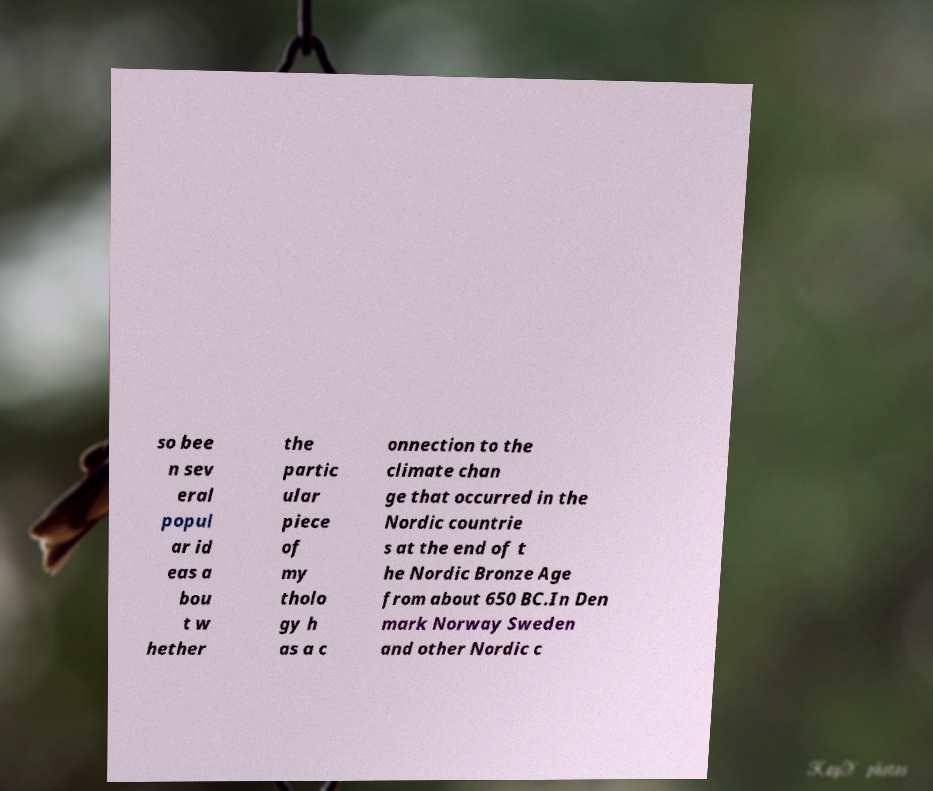I need the written content from this picture converted into text. Can you do that? so bee n sev eral popul ar id eas a bou t w hether the partic ular piece of my tholo gy h as a c onnection to the climate chan ge that occurred in the Nordic countrie s at the end of t he Nordic Bronze Age from about 650 BC.In Den mark Norway Sweden and other Nordic c 